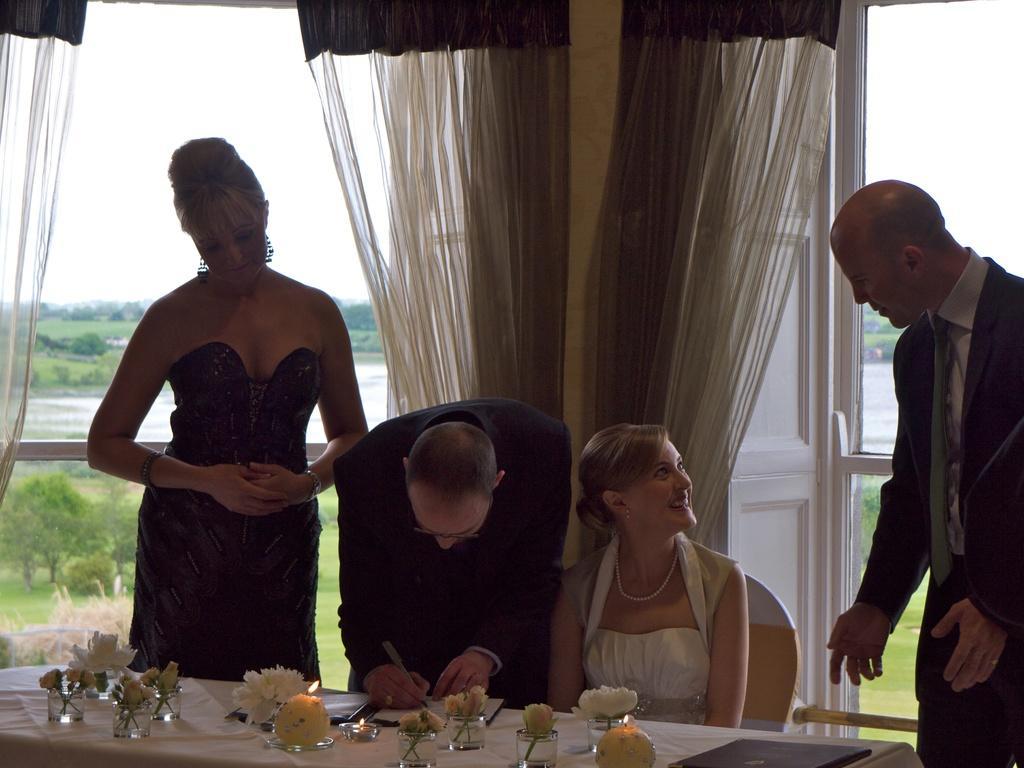Can you describe this image briefly? Two couples are at a table. 